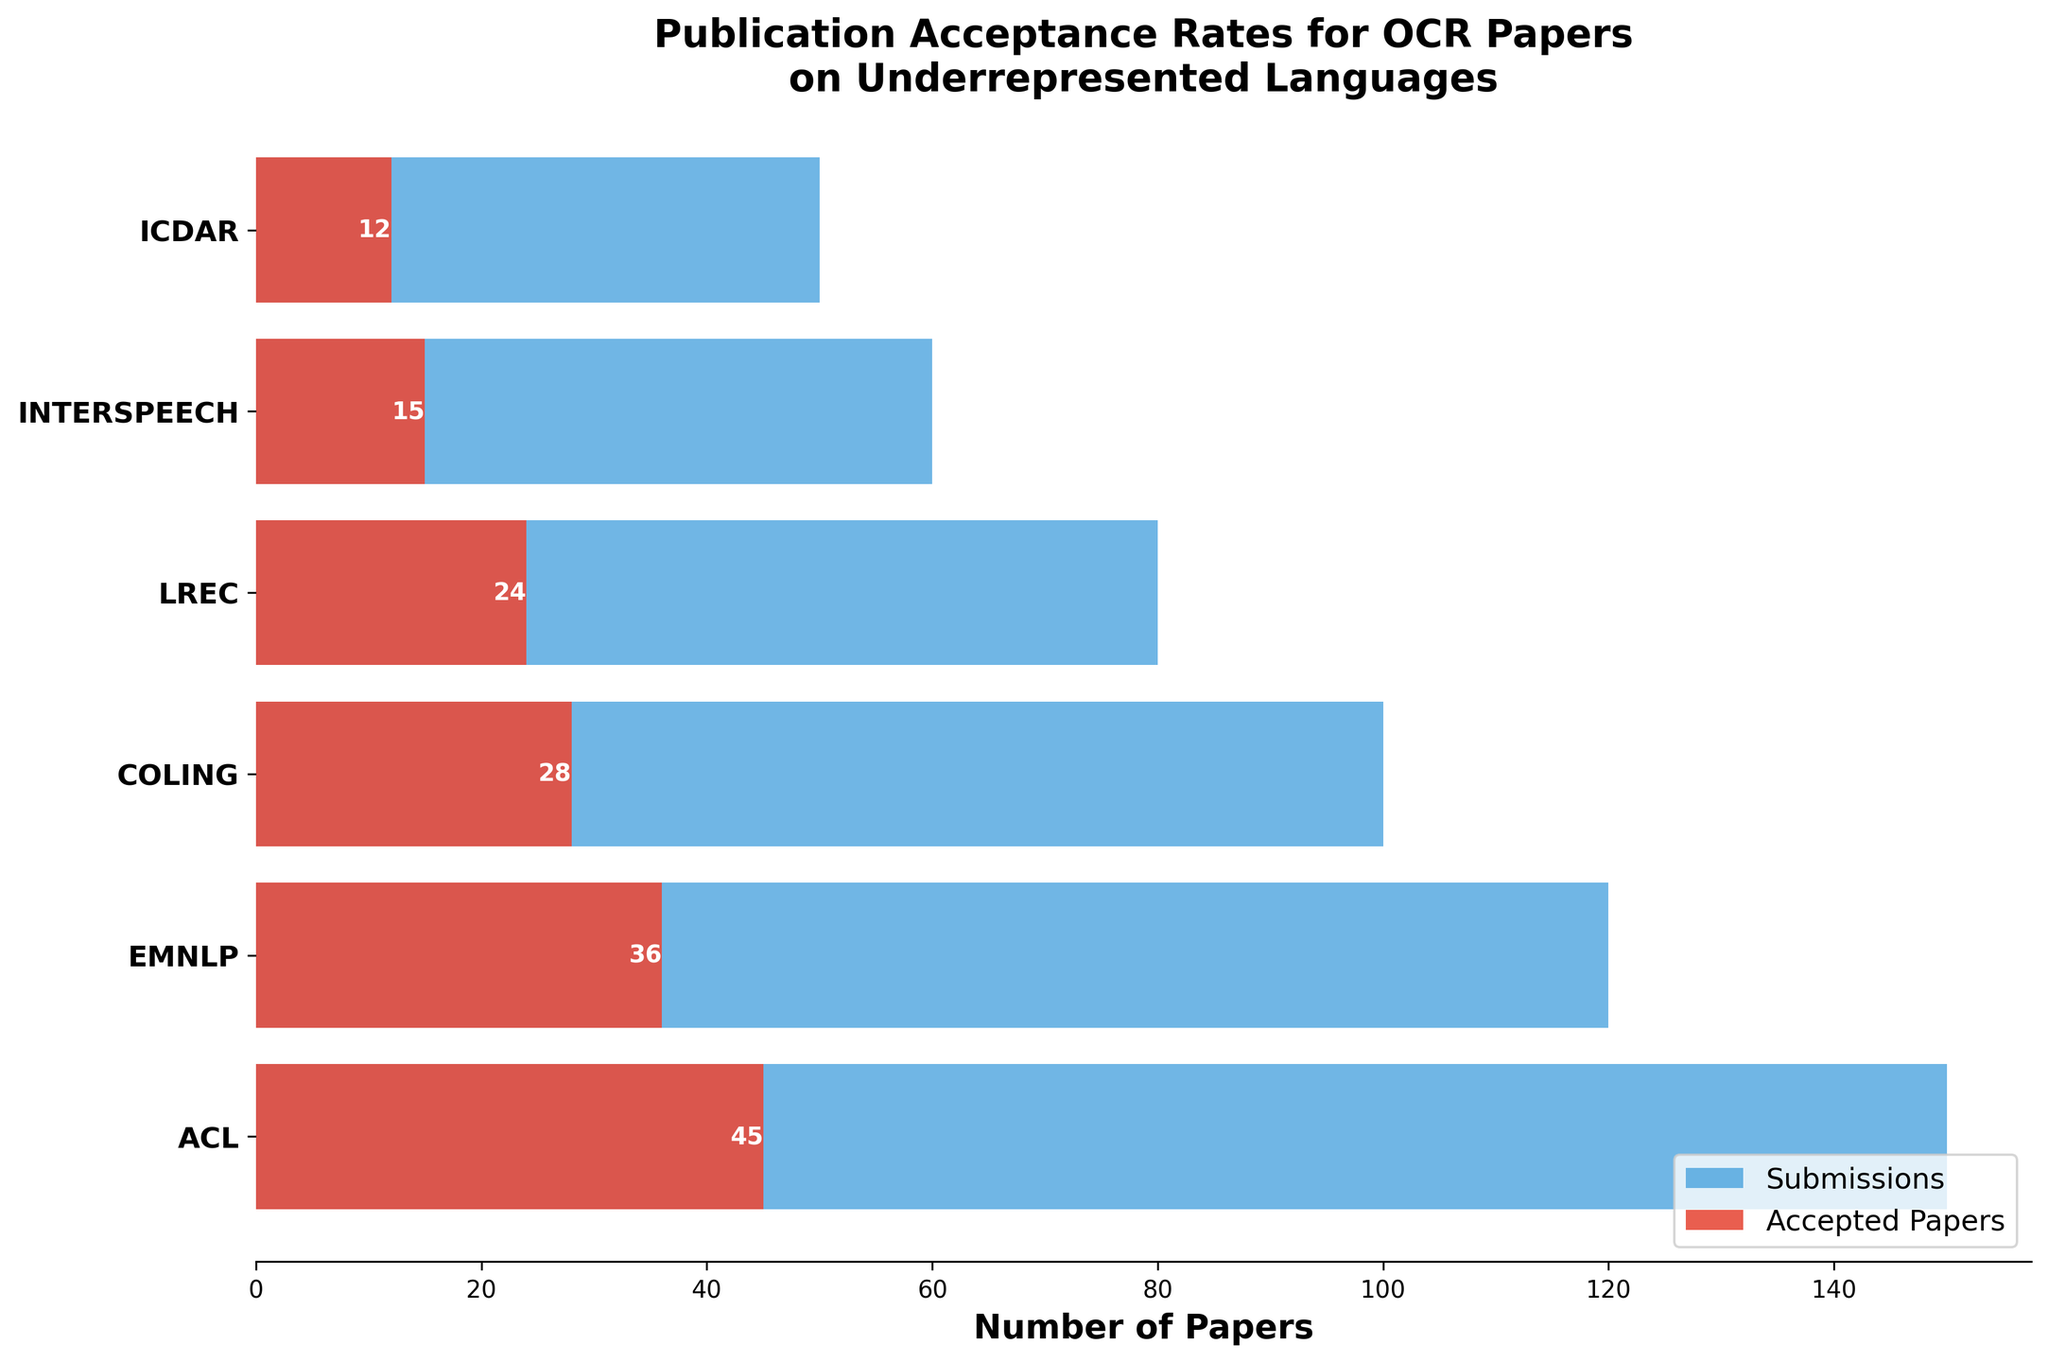How many submissions did EMNLP receive? The figure shows the number of submissions for each conference. Look for the bar labeled "EMNLP" and check the value indicated next to it.
Answer: 120 How many papers were accepted at INTERSPEECH? The figure lists the accepted papers for each conference. Locate the conference "INTERSPEECH" and find the count associated with accepted papers.
Answer: 15 Which conference had the highest number of submissions? Compare the lengths of the blue bars for each conference. The longest bar indicates the highest number of submissions.
Answer: ACL What is the difference between the number of submissions and accepted papers for COLING? Find the values for submissions and accepted papers for COLING. Submissions = 100, Accepted Papers = 28. Then compute the difference: 100 - 28.
Answer: 72 Which conference has the highest acceptance rate? Calculate the acceptance rate (accepted papers/submissions) for each conference and compare. For ACL: 45/150 = 0.30, EMNLP: 36/120 = 0.30, COLING: 28/100 = 0.28, LREC: 24/80 = 0.30, INTERSPEECH: 15/60 = 0.25, ICDAR: 12/50 = 0.24. The highest values are for ACL, EMNLP, and LREC (0.30).
Answer: ACL, EMNLP, and LREC What percentage of submitted papers were accepted at ACL? Find the values for ACL—Submissions: 150, Accepted Papers: 45. Calculate the percentage: (45/150) * 100.
Answer: 30% What is the total number of accepted papers across all conferences? Sum the number of accepted papers from each conference. 45 (ACL) + 36 (EMNLP) + 28 (COLING) + 24 (LREC) + 15 (INTERSPEECH) + 12 (ICDAR).
Answer: 160 Compare the acceptance rates of LREC and ICDAR. Which one is higher? Calculate the acceptance rates for both: LREC = 24/80 = 0.30, ICDAR = 12/50 = 0.24. Compare the results.
Answer: LREC What is the total number of submissions across all conferences? Sum the submissions for each conference. 150 (ACL) + 120 (EMNLP) + 100 (COLING) + 80 (LREC) + 60 (INTERSPEECH) + 50 (ICDAR).
Answer: 560 